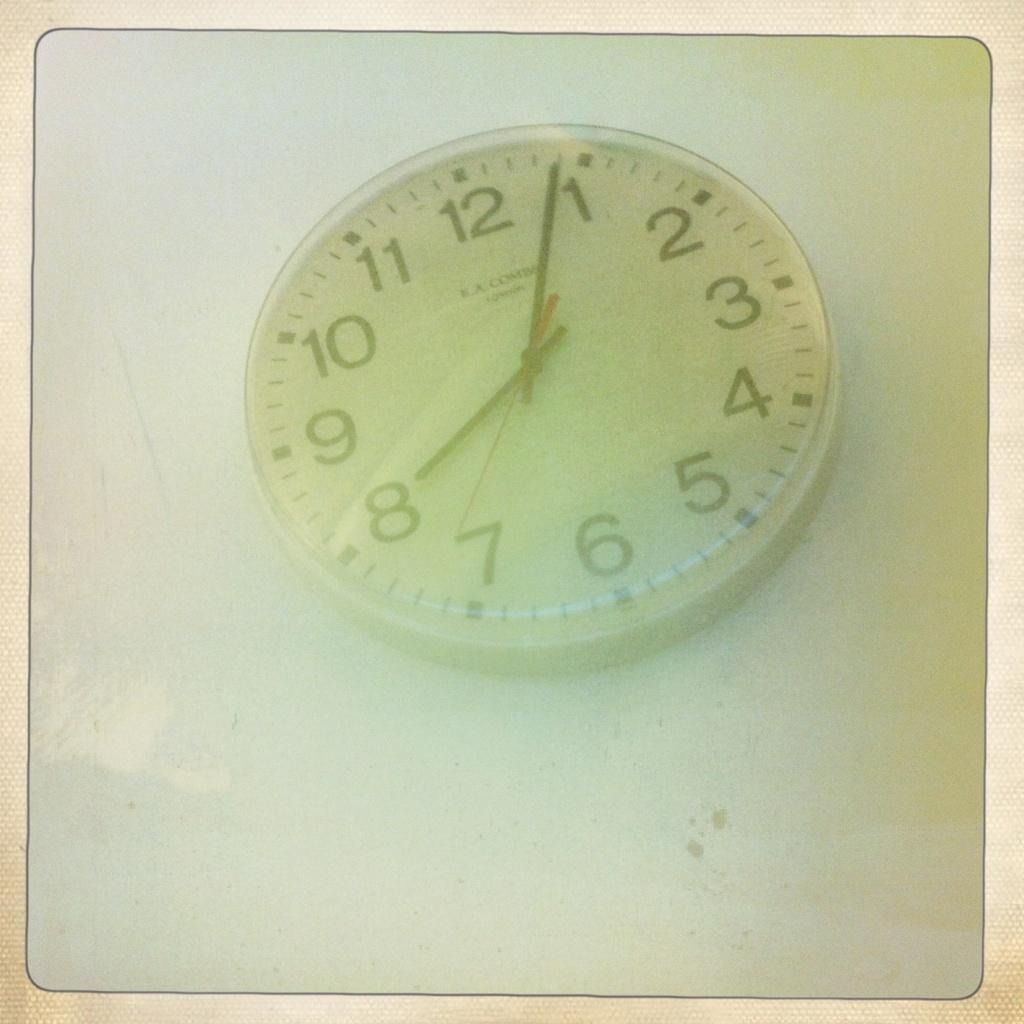<image>
Offer a succinct explanation of the picture presented. White clock with the hands on the numbers 8 and 1. 